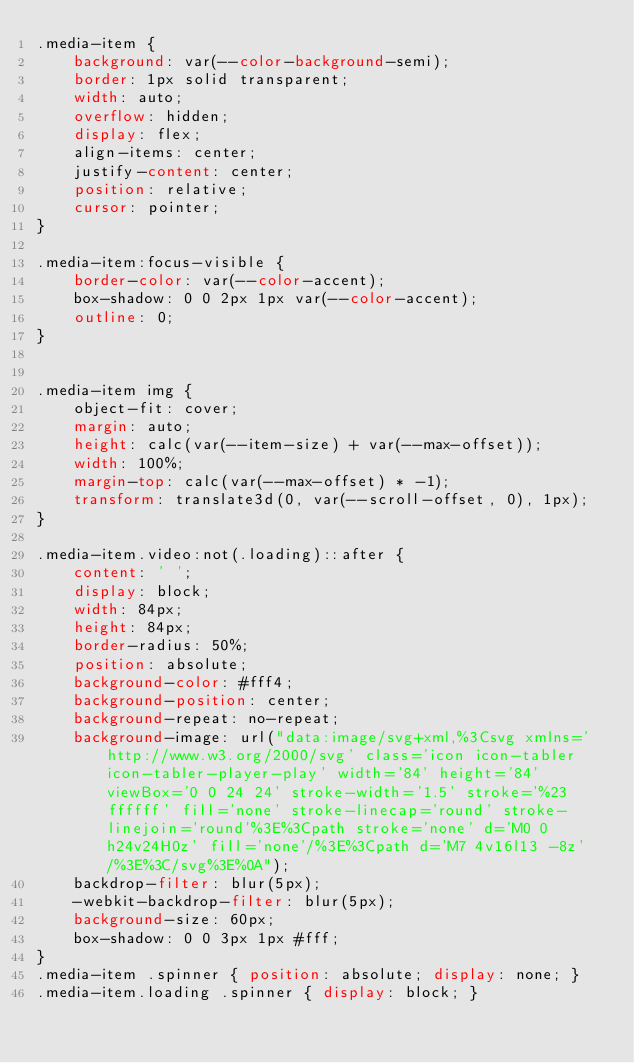Convert code to text. <code><loc_0><loc_0><loc_500><loc_500><_CSS_>.media-item {
	background: var(--color-background-semi);
	border: 1px solid transparent;
	width: auto;
	overflow: hidden;
	display: flex;
	align-items: center;
	justify-content: center;
	position: relative;
	cursor: pointer;
}

.media-item:focus-visible {
	border-color: var(--color-accent);
	box-shadow: 0 0 2px 1px var(--color-accent);
	outline: 0;
}


.media-item img {
	object-fit: cover;
	margin: auto;
	height: calc(var(--item-size) + var(--max-offset));
	width: 100%;
	margin-top: calc(var(--max-offset) * -1);
	transform: translate3d(0, var(--scroll-offset, 0), 1px);
}

.media-item.video:not(.loading)::after {
	content: ' ';
	display: block;
	width: 84px;
	height: 84px;
	border-radius: 50%;
	position: absolute;
	background-color: #fff4;
	background-position: center;
	background-repeat: no-repeat;
	background-image: url("data:image/svg+xml,%3Csvg xmlns='http://www.w3.org/2000/svg' class='icon icon-tabler icon-tabler-player-play' width='84' height='84' viewBox='0 0 24 24' stroke-width='1.5' stroke='%23ffffff' fill='none' stroke-linecap='round' stroke-linejoin='round'%3E%3Cpath stroke='none' d='M0 0h24v24H0z' fill='none'/%3E%3Cpath d='M7 4v16l13 -8z' /%3E%3C/svg%3E%0A");
	backdrop-filter: blur(5px);
	-webkit-backdrop-filter: blur(5px);
	background-size: 60px;
	box-shadow: 0 0 3px 1px #fff;
}
.media-item .spinner { position: absolute; display: none; }
.media-item.loading .spinner { display: block; }
</code> 